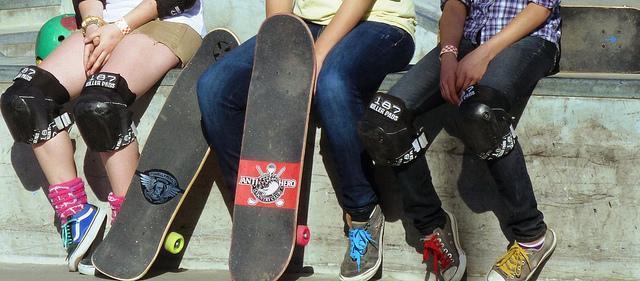How many kids are there?
Give a very brief answer. 3. How many skateboards are there?
Give a very brief answer. 2. How many skateboards are in the picture?
Give a very brief answer. 2. How many people are there?
Give a very brief answer. 3. 